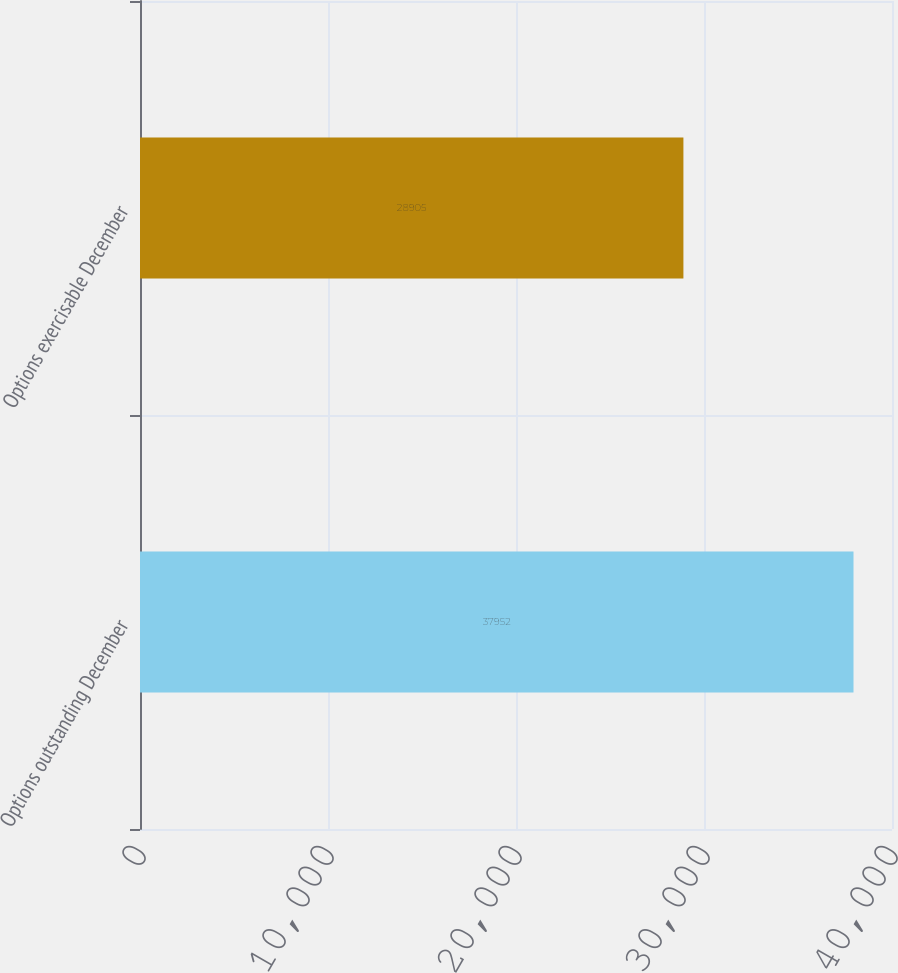<chart> <loc_0><loc_0><loc_500><loc_500><bar_chart><fcel>Options outstanding December<fcel>Options exercisable December<nl><fcel>37952<fcel>28905<nl></chart> 